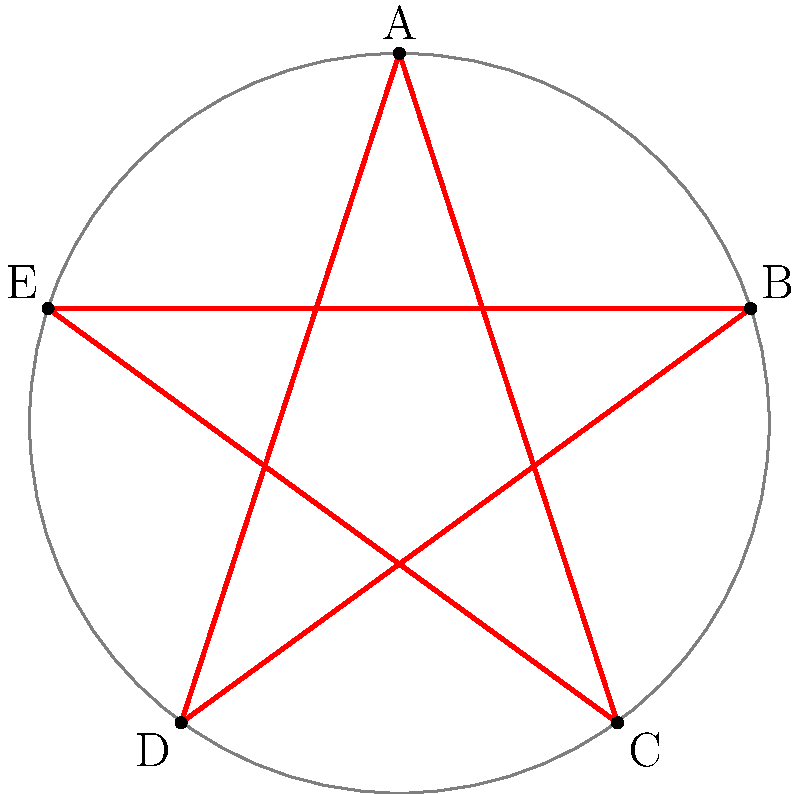In a recent episode of Supernatural, a perfect pentagram was drawn inside a circle with a radius of 2 units. If the pentagram's points touch the circle at points A, B, C, D, and E as shown in the diagram, calculate the area of the pentagram. Round your answer to two decimal places. To calculate the area of the pentagram, we'll follow these steps:

1) First, we need to find the area of the regular pentagon formed by connecting the outer points of the pentagram.

2) The area of a regular pentagon with side length $s$ is given by:
   $$A_{pentagon} = \frac{1}{4}\sqrt{25+10\sqrt{5}}s^2$$

3) To find $s$, we can use the formula for the side length of a regular pentagon inscribed in a circle with radius $r$:
   $$s = 2r\sin(\frac{\pi}{5})$$

4) Given $r = 2$, we can calculate $s$:
   $$s = 2(2)\sin(\frac{\pi}{5}) = 4\sin(\frac{\pi}{5}) \approx 2.3511$$

5) Now we can calculate the area of the pentagon:
   $$A_{pentagon} = \frac{1}{4}\sqrt{25+10\sqrt{5}}(2.3511)^2 \approx 8.5065$$

6) The pentagram is formed by removing 5 small triangles from this pentagon. Each of these triangles has a base of $s$ and a height of $\frac{\sqrt{3}}{2}s$.

7) The area of each small triangle is:
   $$A_{triangle} = \frac{1}{2}s(\frac{\sqrt{3}}{2}s) = \frac{\sqrt{3}}{4}s^2 \approx 1.2016$$

8) The total area to be subtracted is:
   $$5A_{triangle} = 5(1.2016) = 6.0080$$

9) Therefore, the area of the pentagram is:
   $$A_{pentagram} = A_{pentagon} - 5A_{triangle} = 8.5065 - 6.0080 = 2.4985$$

10) Rounding to two decimal places, we get 2.50 square units.
Answer: 2.50 square units 